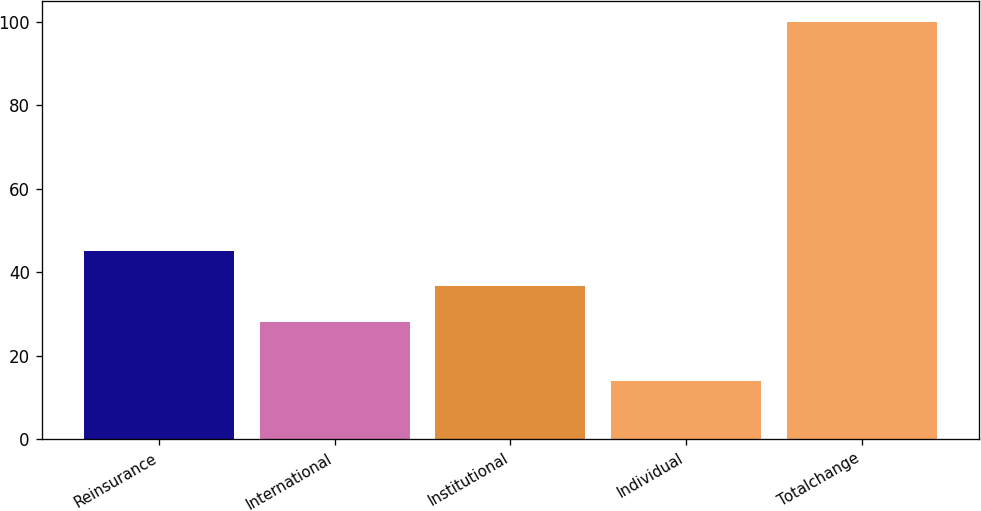Convert chart. <chart><loc_0><loc_0><loc_500><loc_500><bar_chart><fcel>Reinsurance<fcel>International<fcel>Institutional<fcel>Individual<fcel>Totalchange<nl><fcel>45.2<fcel>28<fcel>36.6<fcel>14<fcel>100<nl></chart> 